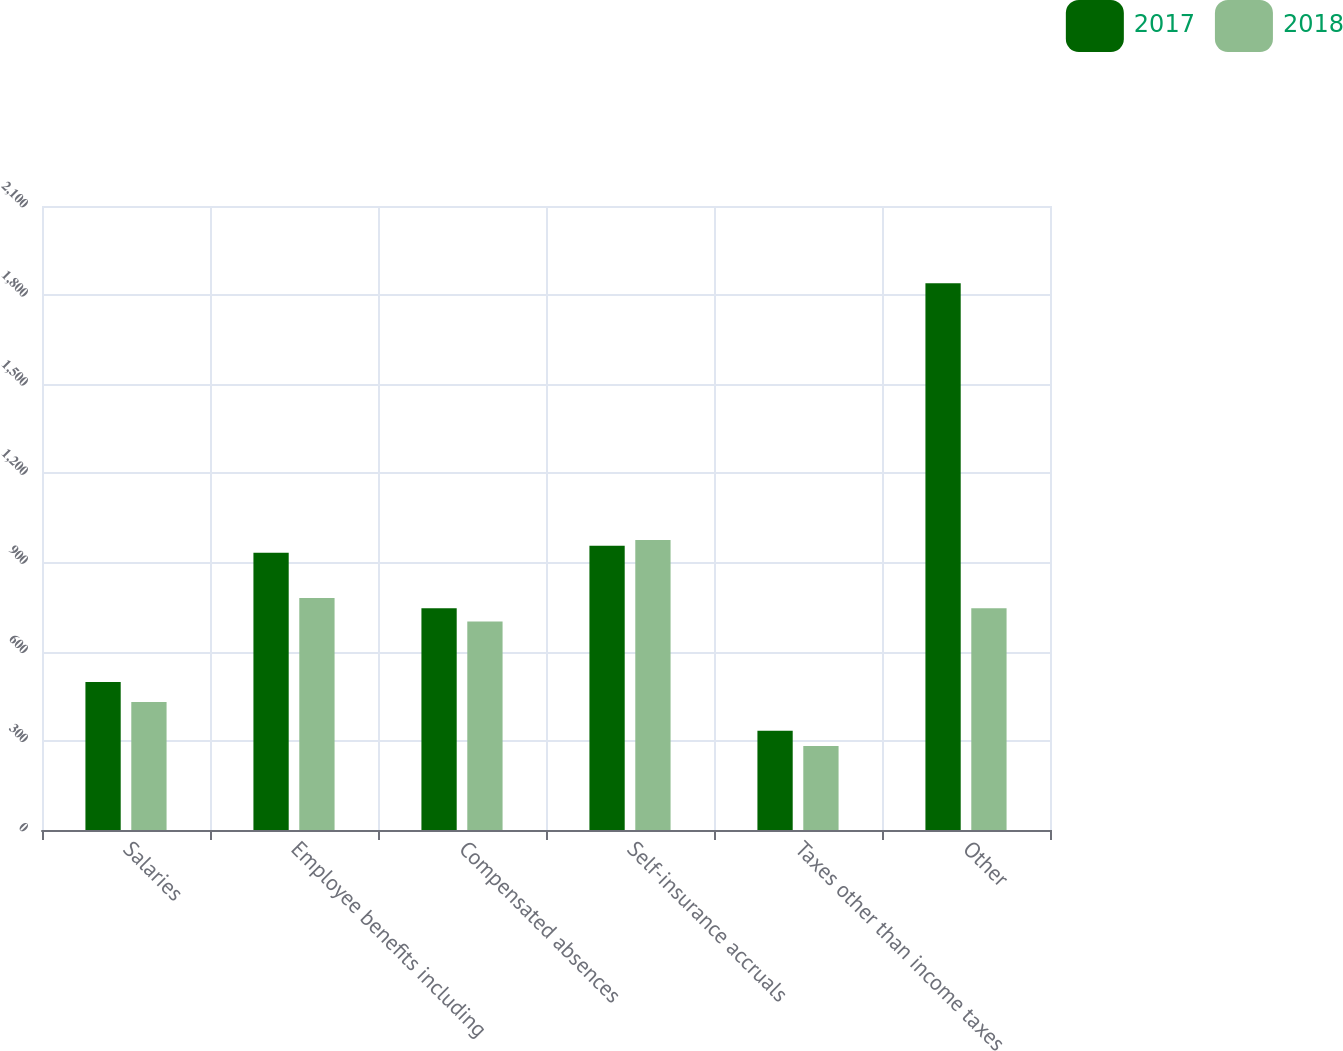Convert chart to OTSL. <chart><loc_0><loc_0><loc_500><loc_500><stacked_bar_chart><ecel><fcel>Salaries<fcel>Employee benefits including<fcel>Compensated absences<fcel>Self-insurance accruals<fcel>Taxes other than income taxes<fcel>Other<nl><fcel>2017<fcel>498<fcel>933<fcel>746<fcel>957<fcel>334<fcel>1840<nl><fcel>2018<fcel>431<fcel>781<fcel>702<fcel>976<fcel>283<fcel>746<nl></chart> 